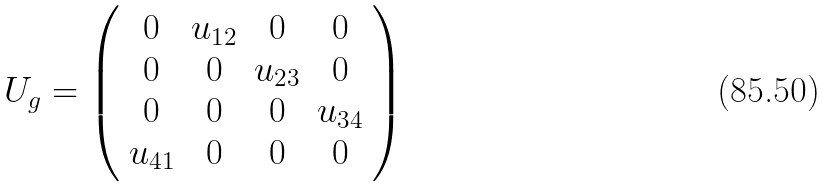Convert formula to latex. <formula><loc_0><loc_0><loc_500><loc_500>U _ { g } = \left ( \begin{array} { c c c c } 0 & u _ { 1 2 } & 0 & 0 \\ 0 & 0 & u _ { 2 3 } & 0 \\ 0 & 0 & 0 & u _ { 3 4 } \\ u _ { 4 1 } & 0 & 0 & 0 \end{array} \right )</formula> 